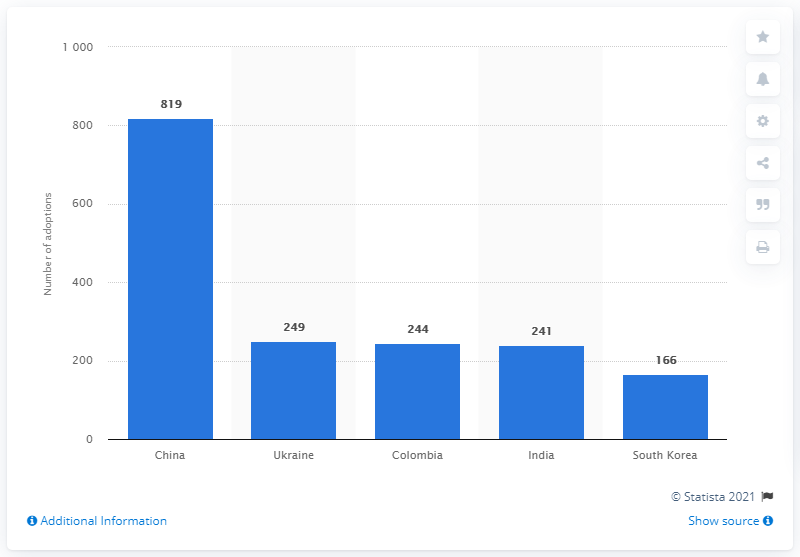Indicate a few pertinent items in this graphic. In 2019, a total of 819 children who had been adopted by American families hailed from China. 